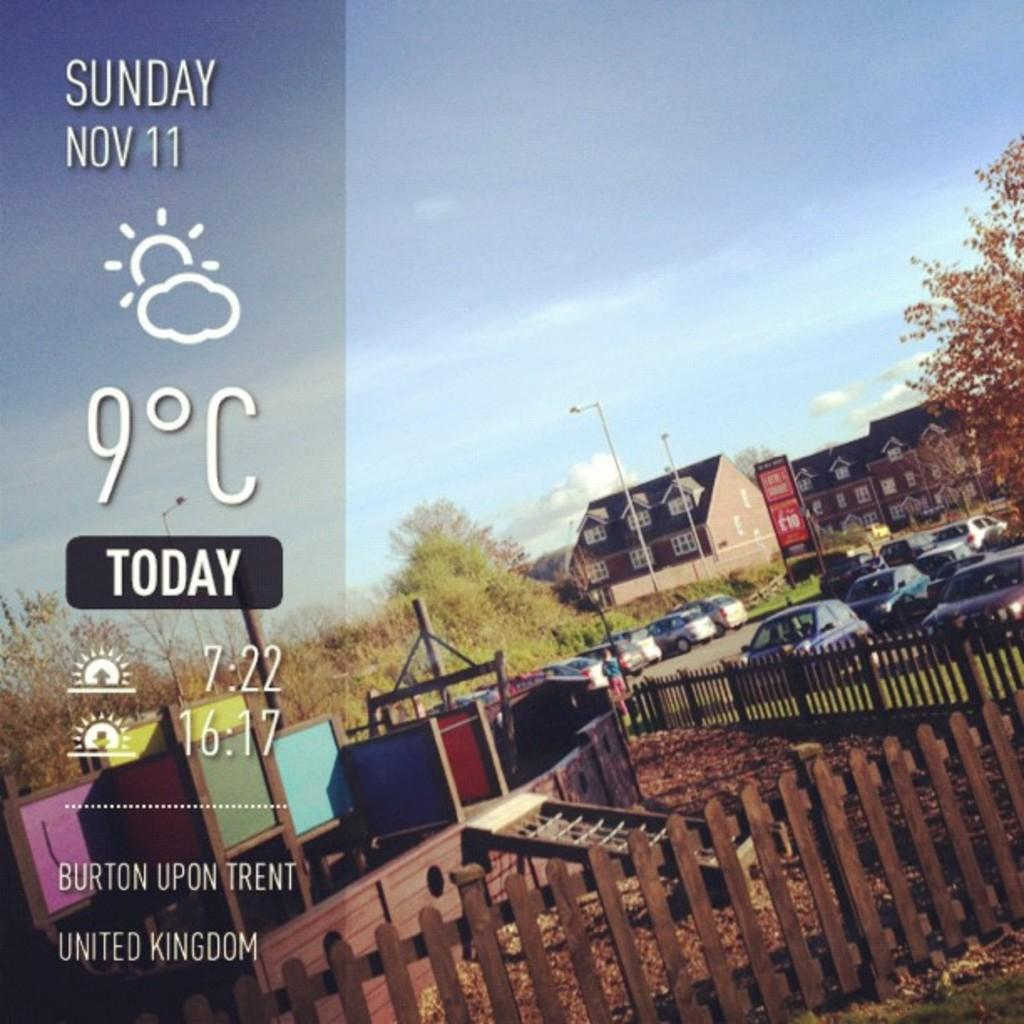<image>
Relay a brief, clear account of the picture shown. The temperature in Burton Upon Trent is currently 9 celsius on Sunday, Nov. 11. 